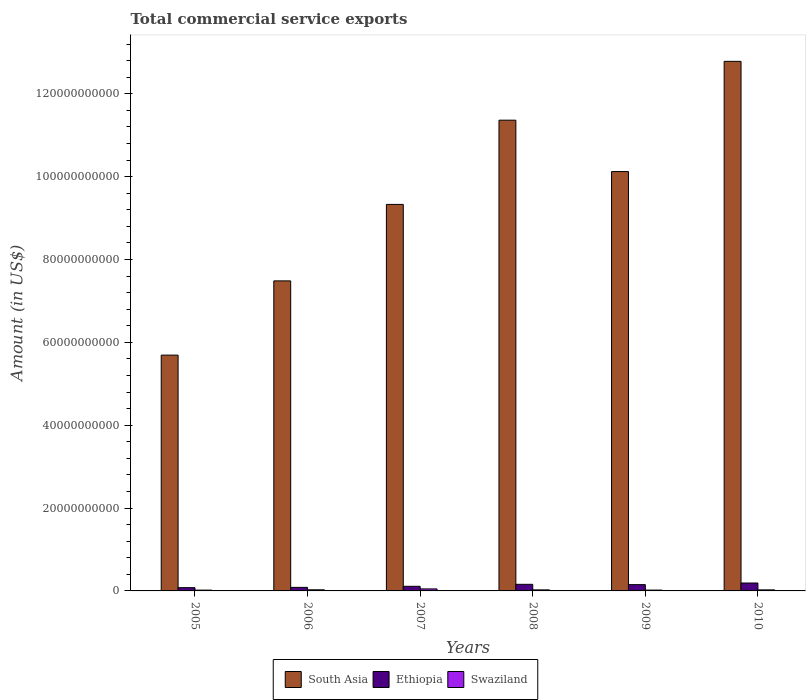How many groups of bars are there?
Make the answer very short. 6. How many bars are there on the 5th tick from the left?
Offer a terse response. 3. In how many cases, is the number of bars for a given year not equal to the number of legend labels?
Provide a succinct answer. 0. What is the total commercial service exports in Swaziland in 2009?
Offer a very short reply. 2.02e+08. Across all years, what is the maximum total commercial service exports in Swaziland?
Provide a succinct answer. 4.86e+08. Across all years, what is the minimum total commercial service exports in South Asia?
Make the answer very short. 5.69e+1. In which year was the total commercial service exports in Ethiopia maximum?
Your answer should be compact. 2010. In which year was the total commercial service exports in Ethiopia minimum?
Give a very brief answer. 2005. What is the total total commercial service exports in Swaziland in the graph?
Provide a short and direct response. 1.65e+09. What is the difference between the total commercial service exports in Ethiopia in 2008 and that in 2010?
Keep it short and to the point. -3.19e+08. What is the difference between the total commercial service exports in South Asia in 2010 and the total commercial service exports in Swaziland in 2009?
Your answer should be very brief. 1.28e+11. What is the average total commercial service exports in South Asia per year?
Give a very brief answer. 9.46e+1. In the year 2010, what is the difference between the total commercial service exports in South Asia and total commercial service exports in Ethiopia?
Your answer should be very brief. 1.26e+11. In how many years, is the total commercial service exports in South Asia greater than 76000000000 US$?
Ensure brevity in your answer.  4. What is the ratio of the total commercial service exports in South Asia in 2007 to that in 2009?
Your response must be concise. 0.92. Is the total commercial service exports in South Asia in 2007 less than that in 2009?
Provide a short and direct response. Yes. What is the difference between the highest and the second highest total commercial service exports in South Asia?
Your answer should be compact. 1.42e+1. What is the difference between the highest and the lowest total commercial service exports in Ethiopia?
Your answer should be very brief. 1.12e+09. In how many years, is the total commercial service exports in South Asia greater than the average total commercial service exports in South Asia taken over all years?
Offer a very short reply. 3. Is the sum of the total commercial service exports in Swaziland in 2005 and 2007 greater than the maximum total commercial service exports in South Asia across all years?
Offer a terse response. No. What does the 2nd bar from the left in 2009 represents?
Provide a short and direct response. Ethiopia. What does the 1st bar from the right in 2010 represents?
Provide a succinct answer. Swaziland. How many bars are there?
Offer a very short reply. 18. Are the values on the major ticks of Y-axis written in scientific E-notation?
Your answer should be very brief. No. Does the graph contain grids?
Your response must be concise. No. How are the legend labels stacked?
Your answer should be compact. Horizontal. What is the title of the graph?
Your answer should be very brief. Total commercial service exports. What is the label or title of the X-axis?
Make the answer very short. Years. What is the Amount (in US$) in South Asia in 2005?
Provide a short and direct response. 5.69e+1. What is the Amount (in US$) of Ethiopia in 2005?
Your response must be concise. 7.89e+08. What is the Amount (in US$) of Swaziland in 2005?
Ensure brevity in your answer.  1.93e+08. What is the Amount (in US$) in South Asia in 2006?
Your response must be concise. 7.48e+1. What is the Amount (in US$) in Ethiopia in 2006?
Your answer should be compact. 8.59e+08. What is the Amount (in US$) of Swaziland in 2006?
Provide a short and direct response. 2.68e+08. What is the Amount (in US$) in South Asia in 2007?
Make the answer very short. 9.33e+1. What is the Amount (in US$) in Ethiopia in 2007?
Give a very brief answer. 1.11e+09. What is the Amount (in US$) of Swaziland in 2007?
Make the answer very short. 4.86e+08. What is the Amount (in US$) of South Asia in 2008?
Offer a terse response. 1.14e+11. What is the Amount (in US$) in Ethiopia in 2008?
Give a very brief answer. 1.59e+09. What is the Amount (in US$) of Swaziland in 2008?
Offer a very short reply. 2.52e+08. What is the Amount (in US$) of South Asia in 2009?
Provide a succinct answer. 1.01e+11. What is the Amount (in US$) of Ethiopia in 2009?
Provide a short and direct response. 1.52e+09. What is the Amount (in US$) in Swaziland in 2009?
Your response must be concise. 2.02e+08. What is the Amount (in US$) in South Asia in 2010?
Provide a short and direct response. 1.28e+11. What is the Amount (in US$) in Ethiopia in 2010?
Offer a very short reply. 1.91e+09. What is the Amount (in US$) of Swaziland in 2010?
Provide a succinct answer. 2.50e+08. Across all years, what is the maximum Amount (in US$) in South Asia?
Provide a short and direct response. 1.28e+11. Across all years, what is the maximum Amount (in US$) of Ethiopia?
Make the answer very short. 1.91e+09. Across all years, what is the maximum Amount (in US$) of Swaziland?
Give a very brief answer. 4.86e+08. Across all years, what is the minimum Amount (in US$) of South Asia?
Make the answer very short. 5.69e+1. Across all years, what is the minimum Amount (in US$) of Ethiopia?
Offer a terse response. 7.89e+08. Across all years, what is the minimum Amount (in US$) of Swaziland?
Give a very brief answer. 1.93e+08. What is the total Amount (in US$) of South Asia in the graph?
Offer a very short reply. 5.68e+11. What is the total Amount (in US$) in Ethiopia in the graph?
Ensure brevity in your answer.  7.78e+09. What is the total Amount (in US$) in Swaziland in the graph?
Make the answer very short. 1.65e+09. What is the difference between the Amount (in US$) of South Asia in 2005 and that in 2006?
Offer a very short reply. -1.79e+1. What is the difference between the Amount (in US$) of Ethiopia in 2005 and that in 2006?
Offer a very short reply. -6.98e+07. What is the difference between the Amount (in US$) of Swaziland in 2005 and that in 2006?
Provide a short and direct response. -7.48e+07. What is the difference between the Amount (in US$) in South Asia in 2005 and that in 2007?
Your answer should be very brief. -3.64e+1. What is the difference between the Amount (in US$) in Ethiopia in 2005 and that in 2007?
Give a very brief answer. -3.25e+08. What is the difference between the Amount (in US$) in Swaziland in 2005 and that in 2007?
Your answer should be very brief. -2.93e+08. What is the difference between the Amount (in US$) of South Asia in 2005 and that in 2008?
Offer a very short reply. -5.67e+1. What is the difference between the Amount (in US$) of Ethiopia in 2005 and that in 2008?
Your answer should be very brief. -8.03e+08. What is the difference between the Amount (in US$) in Swaziland in 2005 and that in 2008?
Provide a succinct answer. -5.90e+07. What is the difference between the Amount (in US$) in South Asia in 2005 and that in 2009?
Ensure brevity in your answer.  -4.43e+1. What is the difference between the Amount (in US$) in Ethiopia in 2005 and that in 2009?
Make the answer very short. -7.27e+08. What is the difference between the Amount (in US$) in Swaziland in 2005 and that in 2009?
Make the answer very short. -8.29e+06. What is the difference between the Amount (in US$) of South Asia in 2005 and that in 2010?
Your answer should be very brief. -7.09e+1. What is the difference between the Amount (in US$) of Ethiopia in 2005 and that in 2010?
Ensure brevity in your answer.  -1.12e+09. What is the difference between the Amount (in US$) in Swaziland in 2005 and that in 2010?
Make the answer very short. -5.71e+07. What is the difference between the Amount (in US$) of South Asia in 2006 and that in 2007?
Your answer should be very brief. -1.85e+1. What is the difference between the Amount (in US$) in Ethiopia in 2006 and that in 2007?
Offer a very short reply. -2.55e+08. What is the difference between the Amount (in US$) in Swaziland in 2006 and that in 2007?
Ensure brevity in your answer.  -2.18e+08. What is the difference between the Amount (in US$) in South Asia in 2006 and that in 2008?
Offer a very short reply. -3.88e+1. What is the difference between the Amount (in US$) in Ethiopia in 2006 and that in 2008?
Keep it short and to the point. -7.34e+08. What is the difference between the Amount (in US$) of Swaziland in 2006 and that in 2008?
Your answer should be compact. 1.58e+07. What is the difference between the Amount (in US$) of South Asia in 2006 and that in 2009?
Give a very brief answer. -2.64e+1. What is the difference between the Amount (in US$) in Ethiopia in 2006 and that in 2009?
Your answer should be compact. -6.57e+08. What is the difference between the Amount (in US$) in Swaziland in 2006 and that in 2009?
Provide a short and direct response. 6.65e+07. What is the difference between the Amount (in US$) of South Asia in 2006 and that in 2010?
Provide a short and direct response. -5.30e+1. What is the difference between the Amount (in US$) of Ethiopia in 2006 and that in 2010?
Provide a short and direct response. -1.05e+09. What is the difference between the Amount (in US$) in Swaziland in 2006 and that in 2010?
Provide a short and direct response. 1.77e+07. What is the difference between the Amount (in US$) of South Asia in 2007 and that in 2008?
Your response must be concise. -2.03e+1. What is the difference between the Amount (in US$) of Ethiopia in 2007 and that in 2008?
Your response must be concise. -4.79e+08. What is the difference between the Amount (in US$) in Swaziland in 2007 and that in 2008?
Give a very brief answer. 2.34e+08. What is the difference between the Amount (in US$) of South Asia in 2007 and that in 2009?
Provide a succinct answer. -7.93e+09. What is the difference between the Amount (in US$) in Ethiopia in 2007 and that in 2009?
Your answer should be very brief. -4.02e+08. What is the difference between the Amount (in US$) of Swaziland in 2007 and that in 2009?
Make the answer very short. 2.84e+08. What is the difference between the Amount (in US$) of South Asia in 2007 and that in 2010?
Your response must be concise. -3.45e+1. What is the difference between the Amount (in US$) in Ethiopia in 2007 and that in 2010?
Offer a terse response. -7.98e+08. What is the difference between the Amount (in US$) in Swaziland in 2007 and that in 2010?
Offer a terse response. 2.36e+08. What is the difference between the Amount (in US$) of South Asia in 2008 and that in 2009?
Keep it short and to the point. 1.24e+1. What is the difference between the Amount (in US$) of Ethiopia in 2008 and that in 2009?
Provide a short and direct response. 7.64e+07. What is the difference between the Amount (in US$) in Swaziland in 2008 and that in 2009?
Make the answer very short. 5.07e+07. What is the difference between the Amount (in US$) in South Asia in 2008 and that in 2010?
Offer a terse response. -1.42e+1. What is the difference between the Amount (in US$) of Ethiopia in 2008 and that in 2010?
Provide a succinct answer. -3.19e+08. What is the difference between the Amount (in US$) in Swaziland in 2008 and that in 2010?
Offer a very short reply. 1.93e+06. What is the difference between the Amount (in US$) in South Asia in 2009 and that in 2010?
Offer a very short reply. -2.66e+1. What is the difference between the Amount (in US$) of Ethiopia in 2009 and that in 2010?
Your answer should be compact. -3.95e+08. What is the difference between the Amount (in US$) of Swaziland in 2009 and that in 2010?
Your answer should be very brief. -4.88e+07. What is the difference between the Amount (in US$) of South Asia in 2005 and the Amount (in US$) of Ethiopia in 2006?
Offer a terse response. 5.61e+1. What is the difference between the Amount (in US$) of South Asia in 2005 and the Amount (in US$) of Swaziland in 2006?
Offer a very short reply. 5.66e+1. What is the difference between the Amount (in US$) in Ethiopia in 2005 and the Amount (in US$) in Swaziland in 2006?
Offer a very short reply. 5.21e+08. What is the difference between the Amount (in US$) of South Asia in 2005 and the Amount (in US$) of Ethiopia in 2007?
Offer a terse response. 5.58e+1. What is the difference between the Amount (in US$) of South Asia in 2005 and the Amount (in US$) of Swaziland in 2007?
Offer a very short reply. 5.64e+1. What is the difference between the Amount (in US$) of Ethiopia in 2005 and the Amount (in US$) of Swaziland in 2007?
Offer a terse response. 3.03e+08. What is the difference between the Amount (in US$) of South Asia in 2005 and the Amount (in US$) of Ethiopia in 2008?
Ensure brevity in your answer.  5.53e+1. What is the difference between the Amount (in US$) of South Asia in 2005 and the Amount (in US$) of Swaziland in 2008?
Your answer should be very brief. 5.67e+1. What is the difference between the Amount (in US$) of Ethiopia in 2005 and the Amount (in US$) of Swaziland in 2008?
Provide a short and direct response. 5.37e+08. What is the difference between the Amount (in US$) of South Asia in 2005 and the Amount (in US$) of Ethiopia in 2009?
Your answer should be compact. 5.54e+1. What is the difference between the Amount (in US$) of South Asia in 2005 and the Amount (in US$) of Swaziland in 2009?
Your answer should be compact. 5.67e+1. What is the difference between the Amount (in US$) of Ethiopia in 2005 and the Amount (in US$) of Swaziland in 2009?
Your answer should be very brief. 5.88e+08. What is the difference between the Amount (in US$) in South Asia in 2005 and the Amount (in US$) in Ethiopia in 2010?
Ensure brevity in your answer.  5.50e+1. What is the difference between the Amount (in US$) of South Asia in 2005 and the Amount (in US$) of Swaziland in 2010?
Provide a short and direct response. 5.67e+1. What is the difference between the Amount (in US$) of Ethiopia in 2005 and the Amount (in US$) of Swaziland in 2010?
Give a very brief answer. 5.39e+08. What is the difference between the Amount (in US$) of South Asia in 2006 and the Amount (in US$) of Ethiopia in 2007?
Provide a short and direct response. 7.37e+1. What is the difference between the Amount (in US$) in South Asia in 2006 and the Amount (in US$) in Swaziland in 2007?
Ensure brevity in your answer.  7.43e+1. What is the difference between the Amount (in US$) in Ethiopia in 2006 and the Amount (in US$) in Swaziland in 2007?
Provide a short and direct response. 3.73e+08. What is the difference between the Amount (in US$) of South Asia in 2006 and the Amount (in US$) of Ethiopia in 2008?
Your response must be concise. 7.32e+1. What is the difference between the Amount (in US$) in South Asia in 2006 and the Amount (in US$) in Swaziland in 2008?
Give a very brief answer. 7.46e+1. What is the difference between the Amount (in US$) in Ethiopia in 2006 and the Amount (in US$) in Swaziland in 2008?
Keep it short and to the point. 6.07e+08. What is the difference between the Amount (in US$) of South Asia in 2006 and the Amount (in US$) of Ethiopia in 2009?
Give a very brief answer. 7.33e+1. What is the difference between the Amount (in US$) of South Asia in 2006 and the Amount (in US$) of Swaziland in 2009?
Offer a terse response. 7.46e+1. What is the difference between the Amount (in US$) in Ethiopia in 2006 and the Amount (in US$) in Swaziland in 2009?
Provide a succinct answer. 6.57e+08. What is the difference between the Amount (in US$) in South Asia in 2006 and the Amount (in US$) in Ethiopia in 2010?
Your response must be concise. 7.29e+1. What is the difference between the Amount (in US$) of South Asia in 2006 and the Amount (in US$) of Swaziland in 2010?
Provide a short and direct response. 7.46e+1. What is the difference between the Amount (in US$) of Ethiopia in 2006 and the Amount (in US$) of Swaziland in 2010?
Give a very brief answer. 6.09e+08. What is the difference between the Amount (in US$) in South Asia in 2007 and the Amount (in US$) in Ethiopia in 2008?
Your answer should be compact. 9.17e+1. What is the difference between the Amount (in US$) in South Asia in 2007 and the Amount (in US$) in Swaziland in 2008?
Your answer should be very brief. 9.30e+1. What is the difference between the Amount (in US$) of Ethiopia in 2007 and the Amount (in US$) of Swaziland in 2008?
Keep it short and to the point. 8.61e+08. What is the difference between the Amount (in US$) of South Asia in 2007 and the Amount (in US$) of Ethiopia in 2009?
Your answer should be very brief. 9.18e+1. What is the difference between the Amount (in US$) in South Asia in 2007 and the Amount (in US$) in Swaziland in 2009?
Offer a very short reply. 9.31e+1. What is the difference between the Amount (in US$) in Ethiopia in 2007 and the Amount (in US$) in Swaziland in 2009?
Offer a terse response. 9.12e+08. What is the difference between the Amount (in US$) of South Asia in 2007 and the Amount (in US$) of Ethiopia in 2010?
Ensure brevity in your answer.  9.14e+1. What is the difference between the Amount (in US$) in South Asia in 2007 and the Amount (in US$) in Swaziland in 2010?
Your answer should be very brief. 9.30e+1. What is the difference between the Amount (in US$) in Ethiopia in 2007 and the Amount (in US$) in Swaziland in 2010?
Offer a very short reply. 8.63e+08. What is the difference between the Amount (in US$) in South Asia in 2008 and the Amount (in US$) in Ethiopia in 2009?
Offer a terse response. 1.12e+11. What is the difference between the Amount (in US$) of South Asia in 2008 and the Amount (in US$) of Swaziland in 2009?
Make the answer very short. 1.13e+11. What is the difference between the Amount (in US$) of Ethiopia in 2008 and the Amount (in US$) of Swaziland in 2009?
Provide a short and direct response. 1.39e+09. What is the difference between the Amount (in US$) in South Asia in 2008 and the Amount (in US$) in Ethiopia in 2010?
Provide a succinct answer. 1.12e+11. What is the difference between the Amount (in US$) in South Asia in 2008 and the Amount (in US$) in Swaziland in 2010?
Make the answer very short. 1.13e+11. What is the difference between the Amount (in US$) of Ethiopia in 2008 and the Amount (in US$) of Swaziland in 2010?
Ensure brevity in your answer.  1.34e+09. What is the difference between the Amount (in US$) of South Asia in 2009 and the Amount (in US$) of Ethiopia in 2010?
Ensure brevity in your answer.  9.93e+1. What is the difference between the Amount (in US$) in South Asia in 2009 and the Amount (in US$) in Swaziland in 2010?
Keep it short and to the point. 1.01e+11. What is the difference between the Amount (in US$) of Ethiopia in 2009 and the Amount (in US$) of Swaziland in 2010?
Provide a succinct answer. 1.27e+09. What is the average Amount (in US$) of South Asia per year?
Ensure brevity in your answer.  9.46e+1. What is the average Amount (in US$) of Ethiopia per year?
Make the answer very short. 1.30e+09. What is the average Amount (in US$) of Swaziland per year?
Offer a very short reply. 2.75e+08. In the year 2005, what is the difference between the Amount (in US$) of South Asia and Amount (in US$) of Ethiopia?
Offer a terse response. 5.61e+1. In the year 2005, what is the difference between the Amount (in US$) of South Asia and Amount (in US$) of Swaziland?
Your answer should be compact. 5.67e+1. In the year 2005, what is the difference between the Amount (in US$) of Ethiopia and Amount (in US$) of Swaziland?
Give a very brief answer. 5.96e+08. In the year 2006, what is the difference between the Amount (in US$) of South Asia and Amount (in US$) of Ethiopia?
Provide a short and direct response. 7.40e+1. In the year 2006, what is the difference between the Amount (in US$) in South Asia and Amount (in US$) in Swaziland?
Keep it short and to the point. 7.46e+1. In the year 2006, what is the difference between the Amount (in US$) in Ethiopia and Amount (in US$) in Swaziland?
Make the answer very short. 5.91e+08. In the year 2007, what is the difference between the Amount (in US$) of South Asia and Amount (in US$) of Ethiopia?
Make the answer very short. 9.22e+1. In the year 2007, what is the difference between the Amount (in US$) of South Asia and Amount (in US$) of Swaziland?
Your answer should be compact. 9.28e+1. In the year 2007, what is the difference between the Amount (in US$) of Ethiopia and Amount (in US$) of Swaziland?
Provide a short and direct response. 6.28e+08. In the year 2008, what is the difference between the Amount (in US$) of South Asia and Amount (in US$) of Ethiopia?
Ensure brevity in your answer.  1.12e+11. In the year 2008, what is the difference between the Amount (in US$) in South Asia and Amount (in US$) in Swaziland?
Provide a succinct answer. 1.13e+11. In the year 2008, what is the difference between the Amount (in US$) of Ethiopia and Amount (in US$) of Swaziland?
Give a very brief answer. 1.34e+09. In the year 2009, what is the difference between the Amount (in US$) in South Asia and Amount (in US$) in Ethiopia?
Ensure brevity in your answer.  9.97e+1. In the year 2009, what is the difference between the Amount (in US$) in South Asia and Amount (in US$) in Swaziland?
Provide a short and direct response. 1.01e+11. In the year 2009, what is the difference between the Amount (in US$) of Ethiopia and Amount (in US$) of Swaziland?
Your answer should be compact. 1.31e+09. In the year 2010, what is the difference between the Amount (in US$) in South Asia and Amount (in US$) in Ethiopia?
Your answer should be very brief. 1.26e+11. In the year 2010, what is the difference between the Amount (in US$) of South Asia and Amount (in US$) of Swaziland?
Your answer should be very brief. 1.28e+11. In the year 2010, what is the difference between the Amount (in US$) of Ethiopia and Amount (in US$) of Swaziland?
Make the answer very short. 1.66e+09. What is the ratio of the Amount (in US$) of South Asia in 2005 to that in 2006?
Provide a short and direct response. 0.76. What is the ratio of the Amount (in US$) in Ethiopia in 2005 to that in 2006?
Your response must be concise. 0.92. What is the ratio of the Amount (in US$) of Swaziland in 2005 to that in 2006?
Ensure brevity in your answer.  0.72. What is the ratio of the Amount (in US$) of South Asia in 2005 to that in 2007?
Your answer should be very brief. 0.61. What is the ratio of the Amount (in US$) in Ethiopia in 2005 to that in 2007?
Provide a short and direct response. 0.71. What is the ratio of the Amount (in US$) in Swaziland in 2005 to that in 2007?
Provide a short and direct response. 0.4. What is the ratio of the Amount (in US$) in South Asia in 2005 to that in 2008?
Give a very brief answer. 0.5. What is the ratio of the Amount (in US$) in Ethiopia in 2005 to that in 2008?
Your answer should be compact. 0.5. What is the ratio of the Amount (in US$) in Swaziland in 2005 to that in 2008?
Offer a very short reply. 0.77. What is the ratio of the Amount (in US$) in South Asia in 2005 to that in 2009?
Ensure brevity in your answer.  0.56. What is the ratio of the Amount (in US$) in Ethiopia in 2005 to that in 2009?
Keep it short and to the point. 0.52. What is the ratio of the Amount (in US$) of Swaziland in 2005 to that in 2009?
Your answer should be very brief. 0.96. What is the ratio of the Amount (in US$) of South Asia in 2005 to that in 2010?
Your answer should be very brief. 0.45. What is the ratio of the Amount (in US$) of Ethiopia in 2005 to that in 2010?
Provide a succinct answer. 0.41. What is the ratio of the Amount (in US$) of Swaziland in 2005 to that in 2010?
Give a very brief answer. 0.77. What is the ratio of the Amount (in US$) in South Asia in 2006 to that in 2007?
Provide a succinct answer. 0.8. What is the ratio of the Amount (in US$) in Ethiopia in 2006 to that in 2007?
Ensure brevity in your answer.  0.77. What is the ratio of the Amount (in US$) in Swaziland in 2006 to that in 2007?
Your answer should be very brief. 0.55. What is the ratio of the Amount (in US$) of South Asia in 2006 to that in 2008?
Keep it short and to the point. 0.66. What is the ratio of the Amount (in US$) of Ethiopia in 2006 to that in 2008?
Ensure brevity in your answer.  0.54. What is the ratio of the Amount (in US$) in Swaziland in 2006 to that in 2008?
Your response must be concise. 1.06. What is the ratio of the Amount (in US$) in South Asia in 2006 to that in 2009?
Your answer should be compact. 0.74. What is the ratio of the Amount (in US$) in Ethiopia in 2006 to that in 2009?
Provide a succinct answer. 0.57. What is the ratio of the Amount (in US$) of Swaziland in 2006 to that in 2009?
Keep it short and to the point. 1.33. What is the ratio of the Amount (in US$) of South Asia in 2006 to that in 2010?
Keep it short and to the point. 0.59. What is the ratio of the Amount (in US$) in Ethiopia in 2006 to that in 2010?
Give a very brief answer. 0.45. What is the ratio of the Amount (in US$) of Swaziland in 2006 to that in 2010?
Offer a very short reply. 1.07. What is the ratio of the Amount (in US$) in South Asia in 2007 to that in 2008?
Ensure brevity in your answer.  0.82. What is the ratio of the Amount (in US$) of Ethiopia in 2007 to that in 2008?
Ensure brevity in your answer.  0.7. What is the ratio of the Amount (in US$) in Swaziland in 2007 to that in 2008?
Provide a short and direct response. 1.93. What is the ratio of the Amount (in US$) of South Asia in 2007 to that in 2009?
Keep it short and to the point. 0.92. What is the ratio of the Amount (in US$) in Ethiopia in 2007 to that in 2009?
Ensure brevity in your answer.  0.73. What is the ratio of the Amount (in US$) of Swaziland in 2007 to that in 2009?
Your response must be concise. 2.41. What is the ratio of the Amount (in US$) in South Asia in 2007 to that in 2010?
Offer a very short reply. 0.73. What is the ratio of the Amount (in US$) of Ethiopia in 2007 to that in 2010?
Your answer should be compact. 0.58. What is the ratio of the Amount (in US$) of Swaziland in 2007 to that in 2010?
Your response must be concise. 1.94. What is the ratio of the Amount (in US$) in South Asia in 2008 to that in 2009?
Ensure brevity in your answer.  1.12. What is the ratio of the Amount (in US$) in Ethiopia in 2008 to that in 2009?
Ensure brevity in your answer.  1.05. What is the ratio of the Amount (in US$) of Swaziland in 2008 to that in 2009?
Offer a very short reply. 1.25. What is the ratio of the Amount (in US$) of Ethiopia in 2008 to that in 2010?
Offer a very short reply. 0.83. What is the ratio of the Amount (in US$) of Swaziland in 2008 to that in 2010?
Ensure brevity in your answer.  1.01. What is the ratio of the Amount (in US$) of South Asia in 2009 to that in 2010?
Make the answer very short. 0.79. What is the ratio of the Amount (in US$) in Ethiopia in 2009 to that in 2010?
Ensure brevity in your answer.  0.79. What is the ratio of the Amount (in US$) of Swaziland in 2009 to that in 2010?
Make the answer very short. 0.81. What is the difference between the highest and the second highest Amount (in US$) of South Asia?
Your answer should be compact. 1.42e+1. What is the difference between the highest and the second highest Amount (in US$) of Ethiopia?
Your answer should be very brief. 3.19e+08. What is the difference between the highest and the second highest Amount (in US$) of Swaziland?
Your answer should be very brief. 2.18e+08. What is the difference between the highest and the lowest Amount (in US$) in South Asia?
Your response must be concise. 7.09e+1. What is the difference between the highest and the lowest Amount (in US$) of Ethiopia?
Your response must be concise. 1.12e+09. What is the difference between the highest and the lowest Amount (in US$) in Swaziland?
Provide a succinct answer. 2.93e+08. 